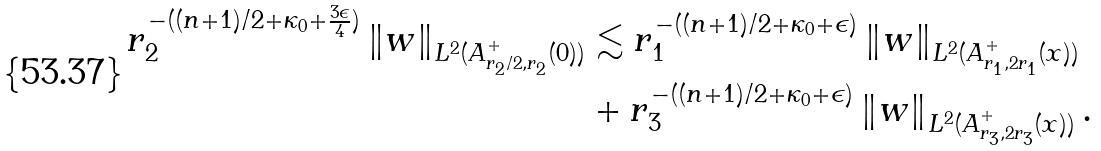<formula> <loc_0><loc_0><loc_500><loc_500>r _ { 2 } ^ { - ( ( n + 1 ) / 2 + \kappa _ { 0 } + \frac { 3 \epsilon } { 4 } ) } \left \| w \right \| _ { L ^ { 2 } ( A ^ { + } _ { r _ { 2 } / 2 , r _ { 2 } } ( 0 ) ) } & \lesssim r _ { 1 } ^ { - ( ( n + 1 ) / 2 + \kappa _ { 0 } + \epsilon ) } \left \| w \right \| _ { L ^ { 2 } ( A ^ { + } _ { r _ { 1 } , 2 r _ { 1 } } ( x ) ) } \\ & + r _ { 3 } ^ { - ( ( n + 1 ) / 2 + \kappa _ { 0 } + \epsilon ) } \left \| w \right \| _ { L ^ { 2 } ( A _ { r _ { 3 } , 2 r _ { 3 } } ^ { + } ( x ) ) } .</formula> 